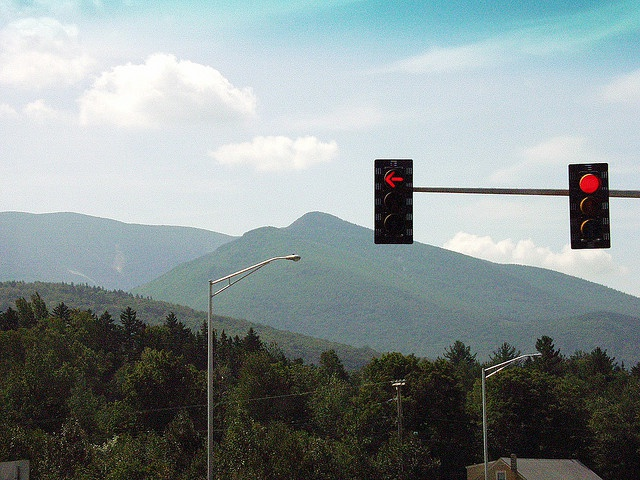Describe the objects in this image and their specific colors. I can see traffic light in lightblue, black, red, lightgray, and maroon tones and traffic light in lightblue, black, gray, red, and maroon tones in this image. 